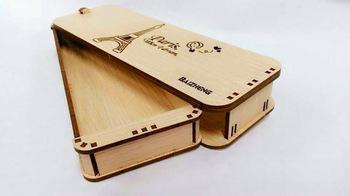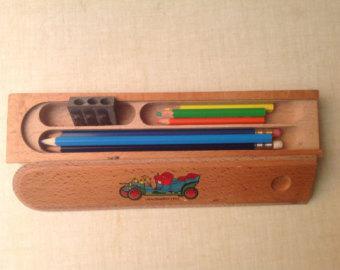The first image is the image on the left, the second image is the image on the right. Evaluate the accuracy of this statement regarding the images: "One image features soft-sided tube-shaped pencil cases with a zipper on top.". Is it true? Answer yes or no. No. The first image is the image on the left, the second image is the image on the right. Assess this claim about the two images: "There is exactly one open pencil case in the image on the right.". Correct or not? Answer yes or no. Yes. 